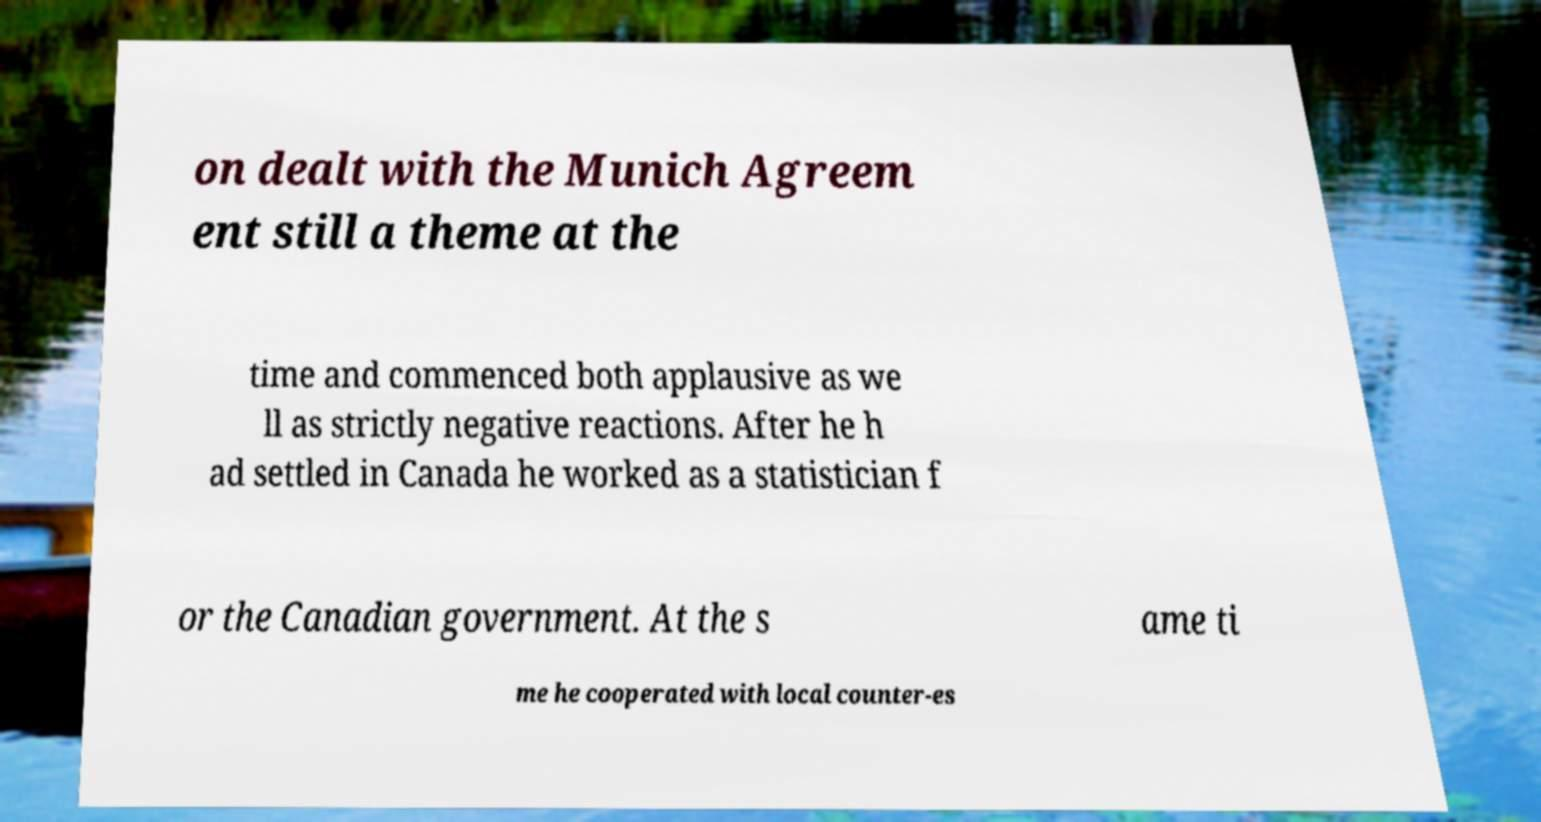For documentation purposes, I need the text within this image transcribed. Could you provide that? on dealt with the Munich Agreem ent still a theme at the time and commenced both applausive as we ll as strictly negative reactions. After he h ad settled in Canada he worked as a statistician f or the Canadian government. At the s ame ti me he cooperated with local counter-es 